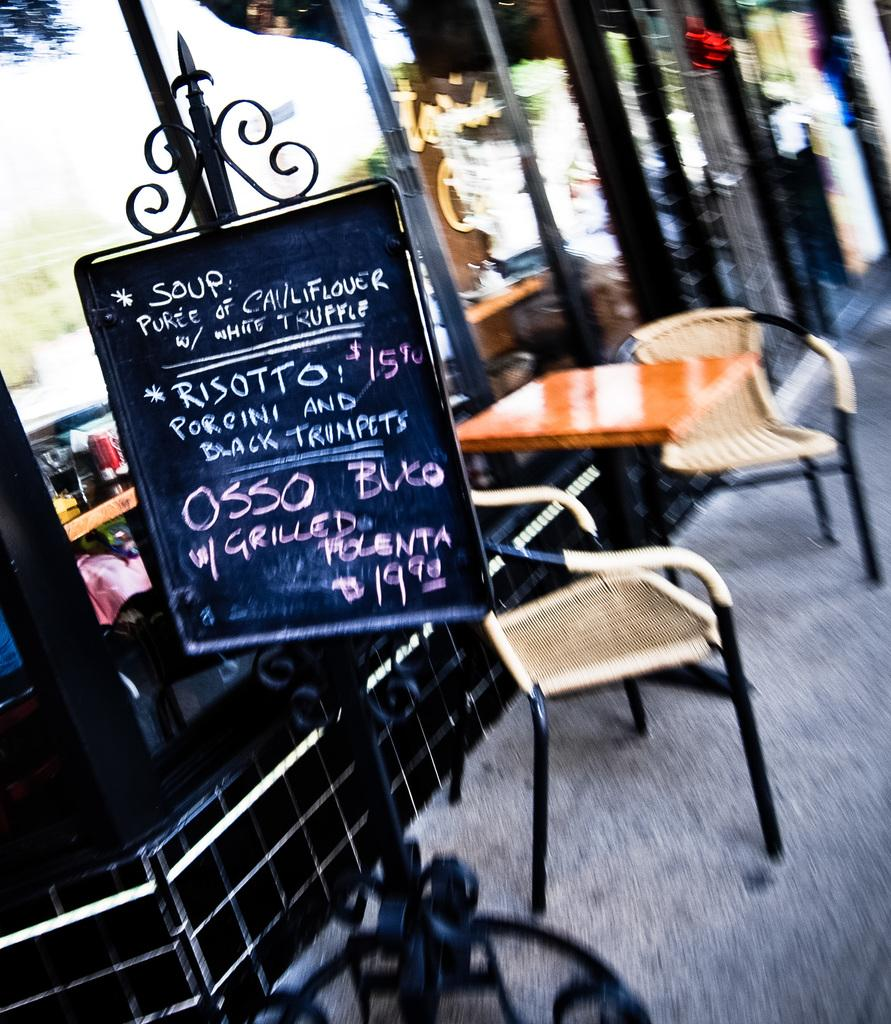What type of furniture is present in the image? There is a table in the image. How many chairs are visible in the image? There are two chairs on the right side of the image. What can be seen in the middle of the image? There is a rate board in the middle of the image. What is visible in the background of the image? There is a building in the background of the image. What type of bean is being used to write on the rate board in the image? There is no bean present in the image, and the rate board does not involve writing with beans. 